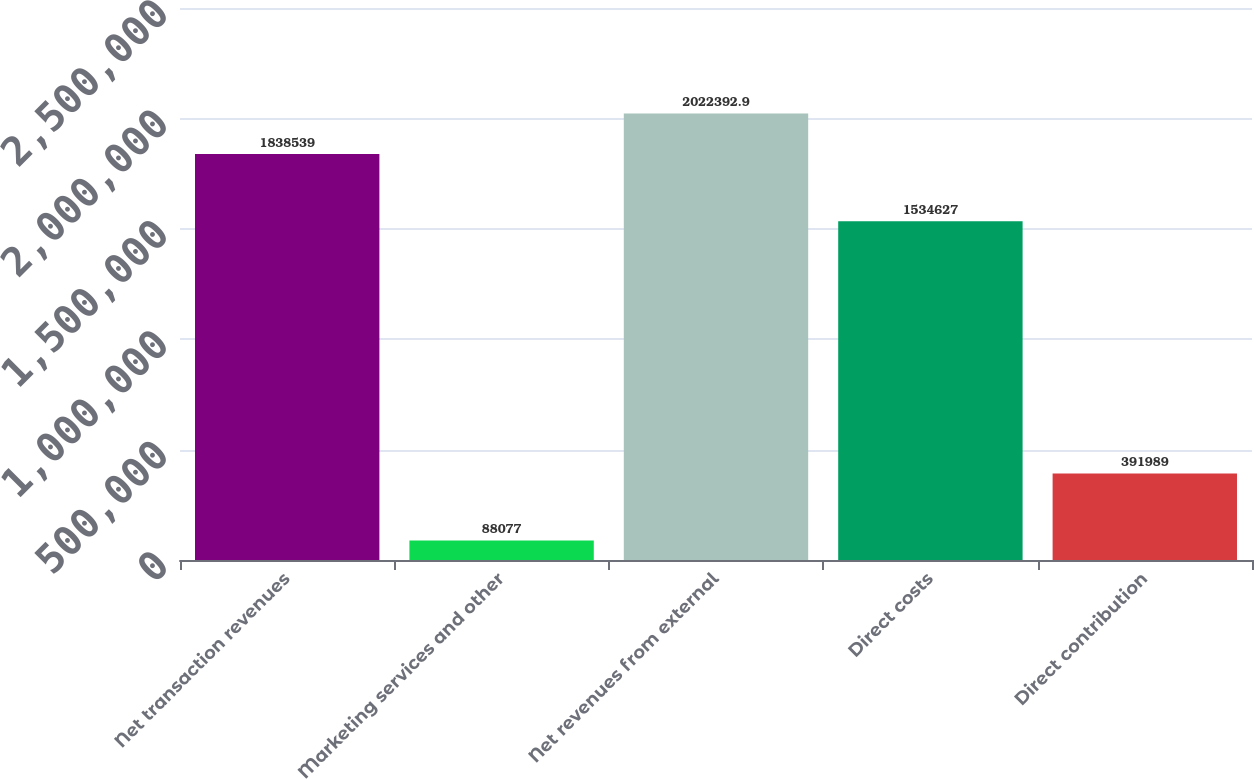<chart> <loc_0><loc_0><loc_500><loc_500><bar_chart><fcel>Net transaction revenues<fcel>Marketing services and other<fcel>Net revenues from external<fcel>Direct costs<fcel>Direct contribution<nl><fcel>1.83854e+06<fcel>88077<fcel>2.02239e+06<fcel>1.53463e+06<fcel>391989<nl></chart> 